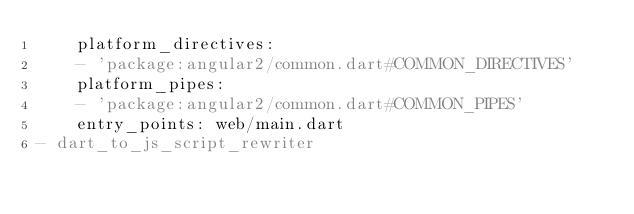<code> <loc_0><loc_0><loc_500><loc_500><_YAML_>    platform_directives:
    - 'package:angular2/common.dart#COMMON_DIRECTIVES'
    platform_pipes:
    - 'package:angular2/common.dart#COMMON_PIPES'
    entry_points: web/main.dart
- dart_to_js_script_rewriter
</code> 